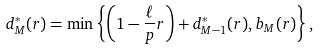<formula> <loc_0><loc_0><loc_500><loc_500>d _ { M } ^ { * } ( r ) = \min \left \{ \left ( 1 - \frac { \ell } { p } r \right ) + d _ { M - 1 } ^ { * } ( r ) , b _ { M } ( r ) \right \} ,</formula> 